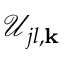<formula> <loc_0><loc_0><loc_500><loc_500>\mathcal { U } _ { j l , { k } }</formula> 